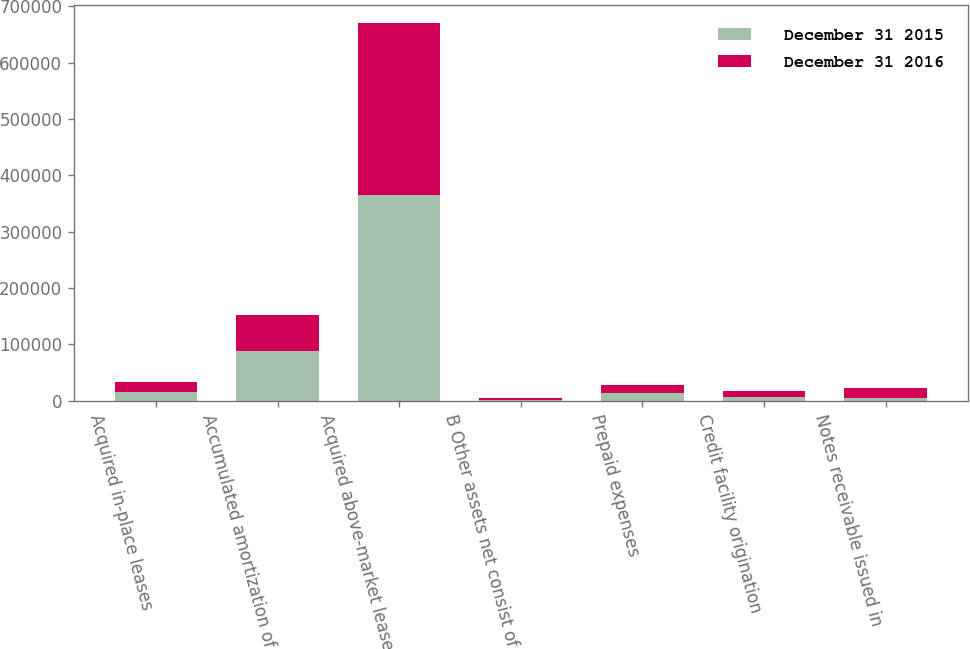Convert chart to OTSL. <chart><loc_0><loc_0><loc_500><loc_500><stacked_bar_chart><ecel><fcel>Acquired in-place leases<fcel>Accumulated amortization of<fcel>Acquired above-market leases<fcel>B Other assets net consist of<fcel>Prepaid expenses<fcel>Credit facility origination<fcel>Notes receivable issued in<nl><fcel>December 31 2015<fcel>16155.5<fcel>88720<fcel>365005<fcel>2016<fcel>14406<fcel>7303<fcel>5390<nl><fcel>December 31 2016<fcel>16155.5<fcel>62447<fcel>304548<fcel>2015<fcel>14258<fcel>10226<fcel>17905<nl></chart> 